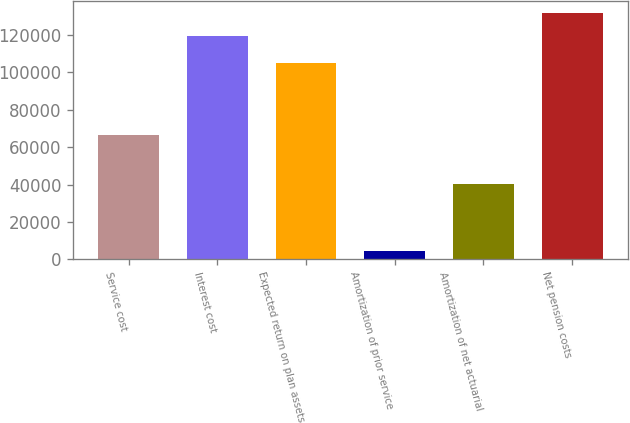<chart> <loc_0><loc_0><loc_500><loc_500><bar_chart><fcel>Service cost<fcel>Interest cost<fcel>Expected return on plan assets<fcel>Amortization of prior service<fcel>Amortization of net actuarial<fcel>Net pension costs<nl><fcel>66650<fcel>119593<fcel>104860<fcel>4209<fcel>40526<fcel>131784<nl></chart> 